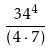Convert formula to latex. <formula><loc_0><loc_0><loc_500><loc_500>\frac { 3 4 ^ { 4 } } { ( 4 \cdot 7 ) }</formula> 